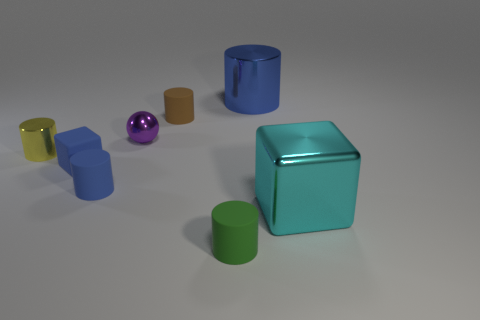Are there the same number of yellow metallic cylinders behind the yellow metallic thing and tiny red shiny cylinders?
Offer a terse response. Yes. There is a small matte cube; are there any things behind it?
Offer a very short reply. Yes. There is a cyan object; is it the same shape as the blue thing that is on the right side of the tiny green rubber object?
Ensure brevity in your answer.  No. There is a small cylinder that is the same material as the large blue cylinder; what is its color?
Provide a succinct answer. Yellow. The rubber cube has what color?
Offer a terse response. Blue. Does the yellow thing have the same material as the large object behind the small purple sphere?
Offer a terse response. Yes. What number of things are behind the green rubber cylinder and to the left of the big cyan thing?
Offer a very short reply. 6. There is a purple object that is the same size as the blue matte block; what shape is it?
Keep it short and to the point. Sphere. There is a big object that is to the left of the large shiny object that is to the right of the large cylinder; are there any tiny green matte objects in front of it?
Offer a very short reply. Yes. Is the color of the small cube the same as the large metallic object that is behind the blue rubber block?
Your response must be concise. Yes. 